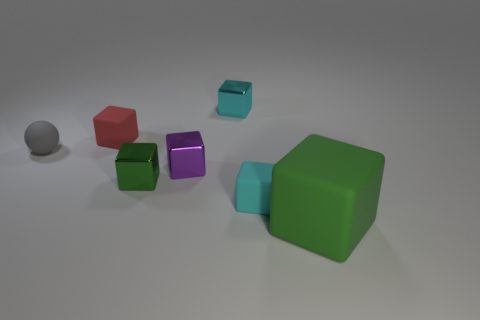Subtract all large green cubes. How many cubes are left? 5 Subtract all cubes. How many objects are left? 1 Subtract 2 cubes. How many cubes are left? 4 Subtract all cyan blocks. Subtract all red spheres. How many blocks are left? 4 Subtract all brown spheres. How many cyan cubes are left? 2 Subtract all shiny blocks. Subtract all tiny metal things. How many objects are left? 1 Add 4 tiny matte cubes. How many tiny matte cubes are left? 6 Add 3 tiny red objects. How many tiny red objects exist? 4 Add 1 large purple matte spheres. How many objects exist? 8 Subtract all red blocks. How many blocks are left? 5 